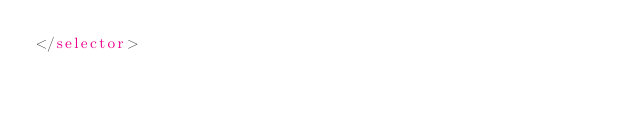Convert code to text. <code><loc_0><loc_0><loc_500><loc_500><_XML_></selector></code> 